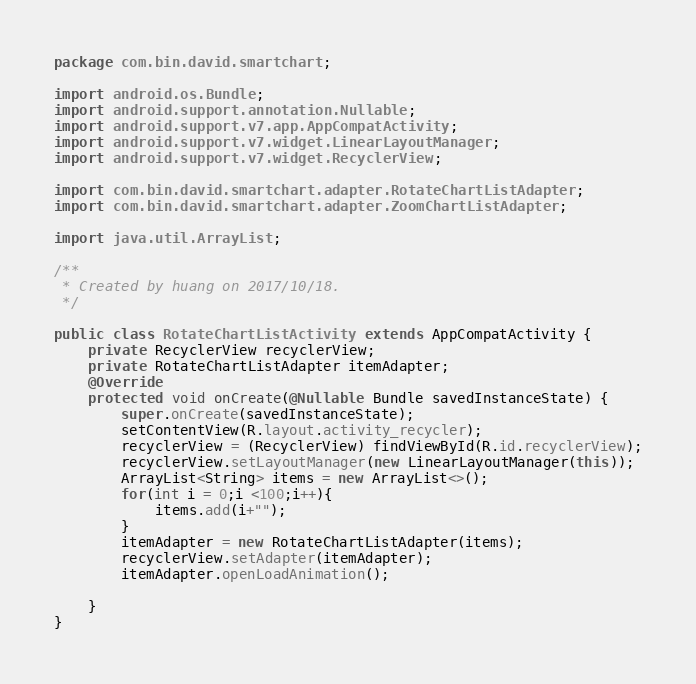Convert code to text. <code><loc_0><loc_0><loc_500><loc_500><_Java_>package com.bin.david.smartchart;

import android.os.Bundle;
import android.support.annotation.Nullable;
import android.support.v7.app.AppCompatActivity;
import android.support.v7.widget.LinearLayoutManager;
import android.support.v7.widget.RecyclerView;

import com.bin.david.smartchart.adapter.RotateChartListAdapter;
import com.bin.david.smartchart.adapter.ZoomChartListAdapter;

import java.util.ArrayList;

/**
 * Created by huang on 2017/10/18.
 */

public class RotateChartListActivity extends AppCompatActivity {
    private RecyclerView recyclerView;
    private RotateChartListAdapter itemAdapter;
    @Override
    protected void onCreate(@Nullable Bundle savedInstanceState) {
        super.onCreate(savedInstanceState);
        setContentView(R.layout.activity_recycler);
        recyclerView = (RecyclerView) findViewById(R.id.recyclerView);
        recyclerView.setLayoutManager(new LinearLayoutManager(this));
        ArrayList<String> items = new ArrayList<>();
        for(int i = 0;i <100;i++){
            items.add(i+"");
        }
        itemAdapter = new RotateChartListAdapter(items);
        recyclerView.setAdapter(itemAdapter);
        itemAdapter.openLoadAnimation();

    }
}
</code> 